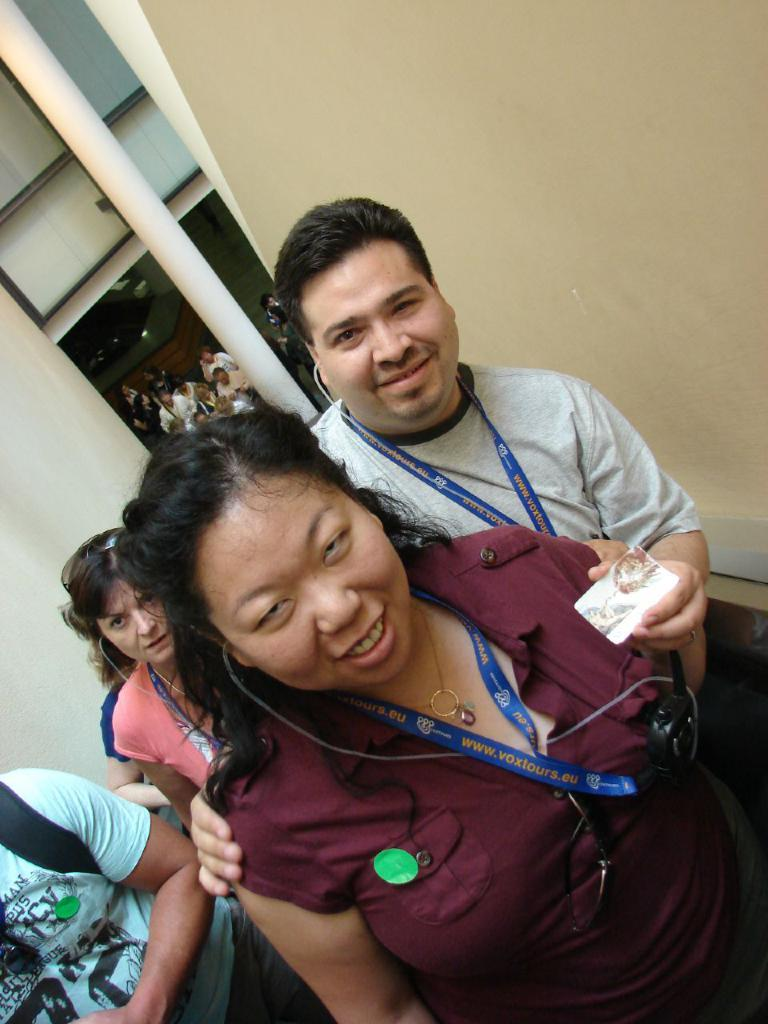What can be seen in the foreground of the image? There are people standing in the foreground of the image. What is located in the background of the image? There is a pillar in the background of the image. What architectural feature is present in the image? There is a wall in the image. How many ladybugs are crawling on the wall in the image? There are no ladybugs present in the image; it only features people, a pillar, and a wall. What type of cracker is being used as a guide for the people in the image? There is no cracker or guide present in the image. 